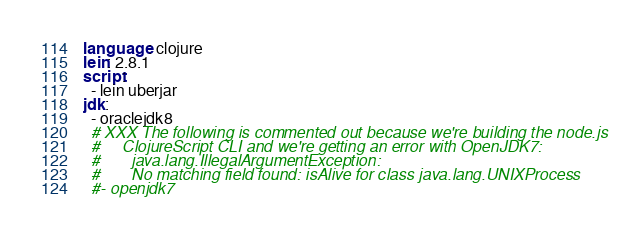<code> <loc_0><loc_0><loc_500><loc_500><_YAML_>language: clojure
lein: 2.8.1
script:
  - lein uberjar
jdk:
  - oraclejdk8
  # XXX The following is commented out because we're building the node.js
  #     ClojureScript CLI and we're getting an error with OpenJDK7:
  #       java.lang.IllegalArgumentException:
  #       No matching field found: isAlive for class java.lang.UNIXProcess
  #- openjdk7
</code> 